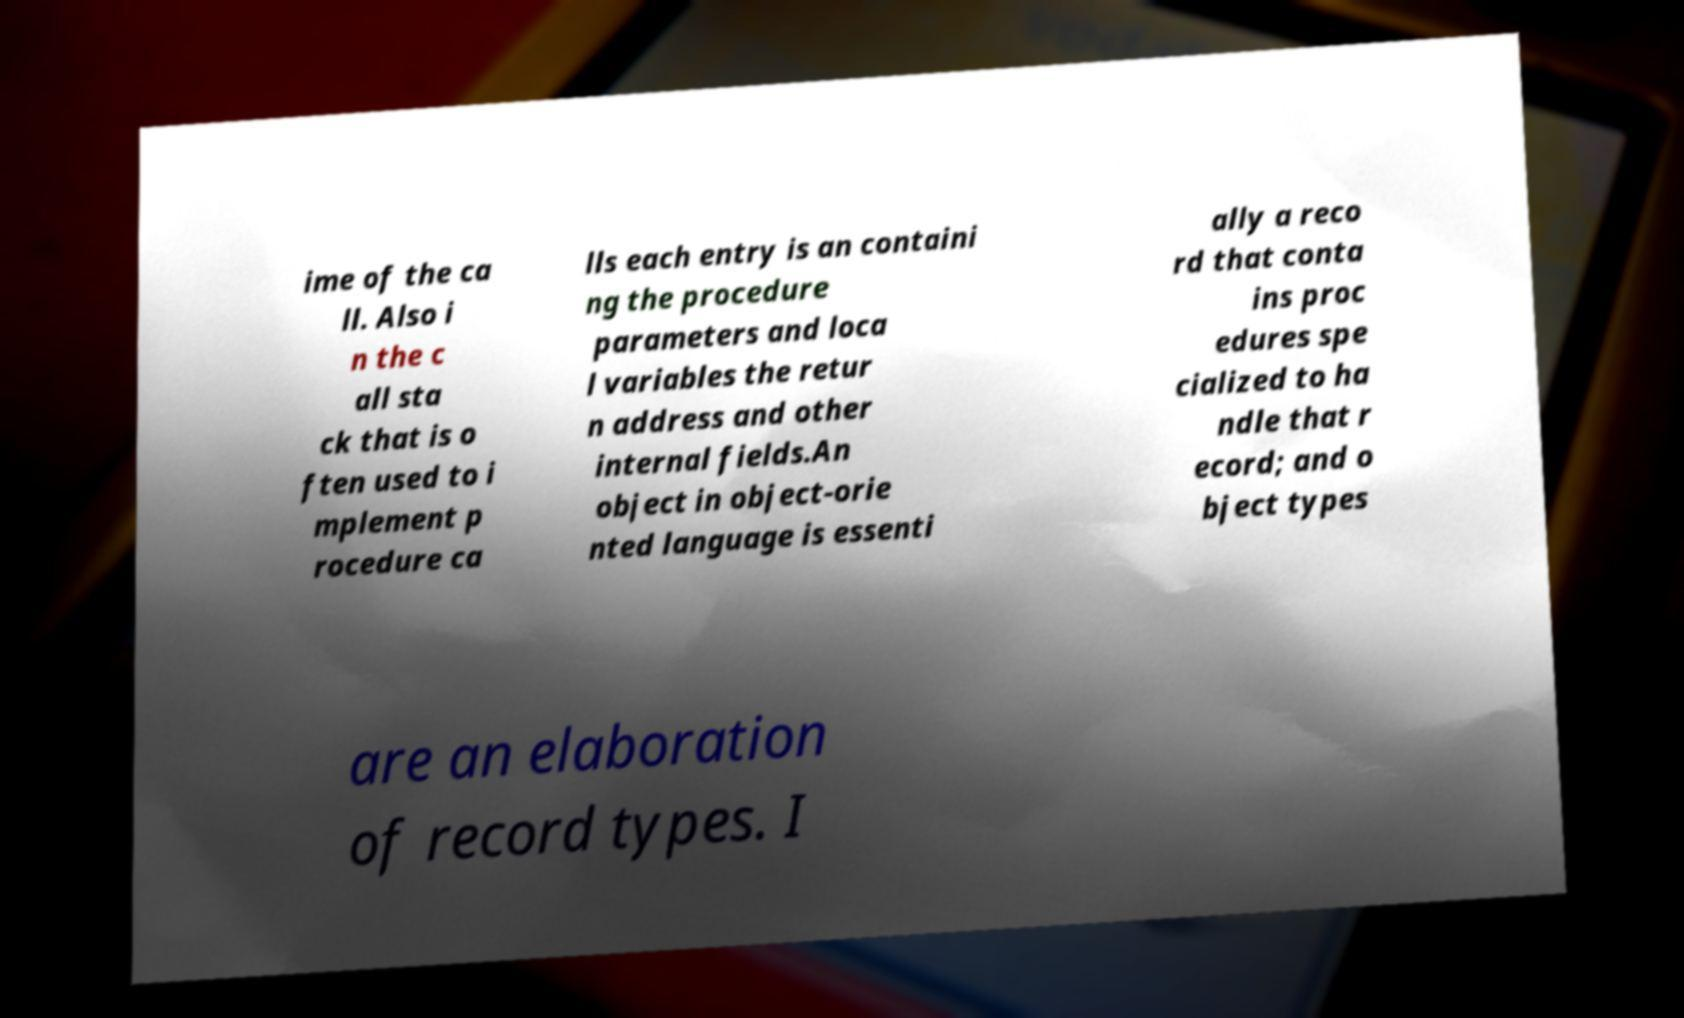Can you accurately transcribe the text from the provided image for me? ime of the ca ll. Also i n the c all sta ck that is o ften used to i mplement p rocedure ca lls each entry is an containi ng the procedure parameters and loca l variables the retur n address and other internal fields.An object in object-orie nted language is essenti ally a reco rd that conta ins proc edures spe cialized to ha ndle that r ecord; and o bject types are an elaboration of record types. I 